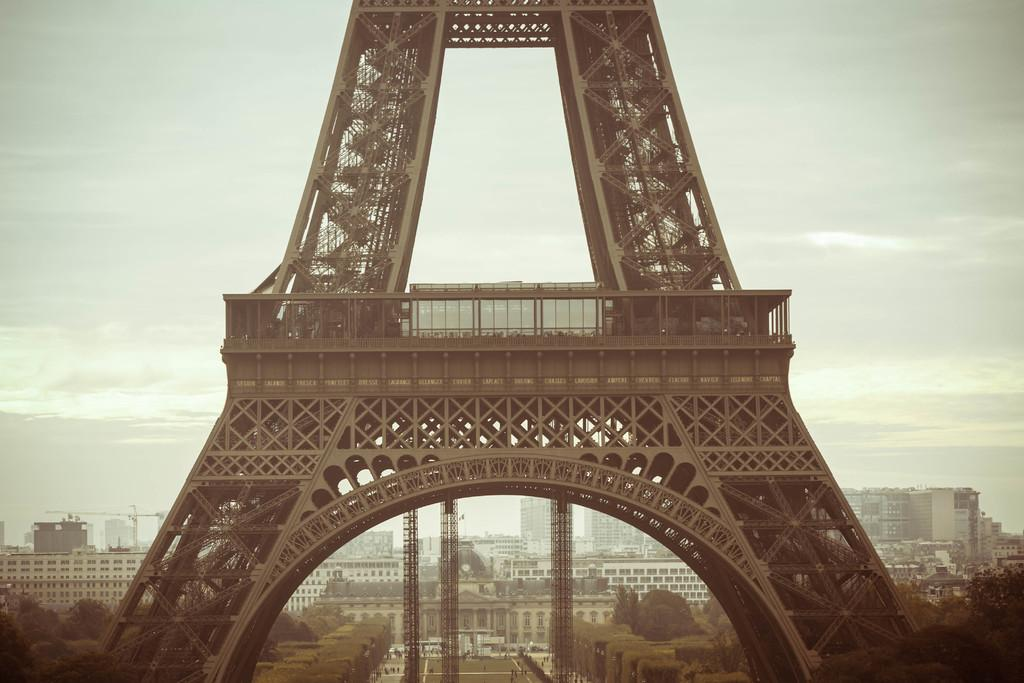What type of structures can be seen in the image? There are towers, buildings, and trees in the image. Are there any living beings present in the image? Yes, there are people in the image. What is the condition of the sky in the image? The sky is cloudy in the image. What type of pathway is visible in the image? There is a road in the image. What else can be seen in the image besides the mentioned elements? There are unspecified objects in the image. How many tickets are visible in the image? There are no tickets present in the image. What type of material is the creator using to rub on the buildings? There is no mention of a creator or any rubbing material in the image. 